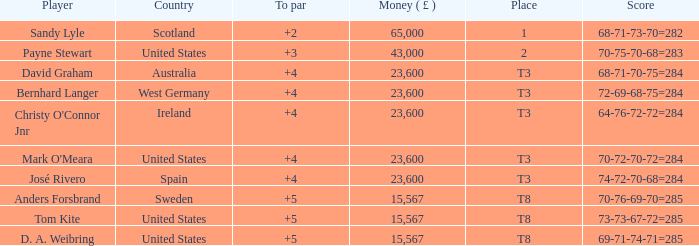What place is David Graham in? T3. 